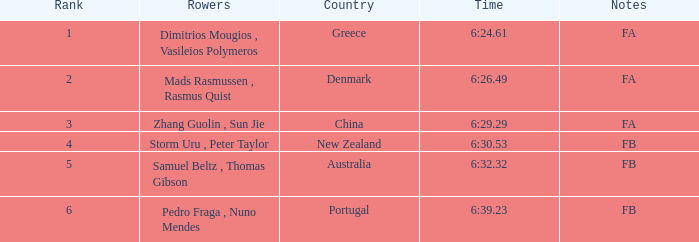61? Dimitrios Mougios , Vasileios Polymeros. 